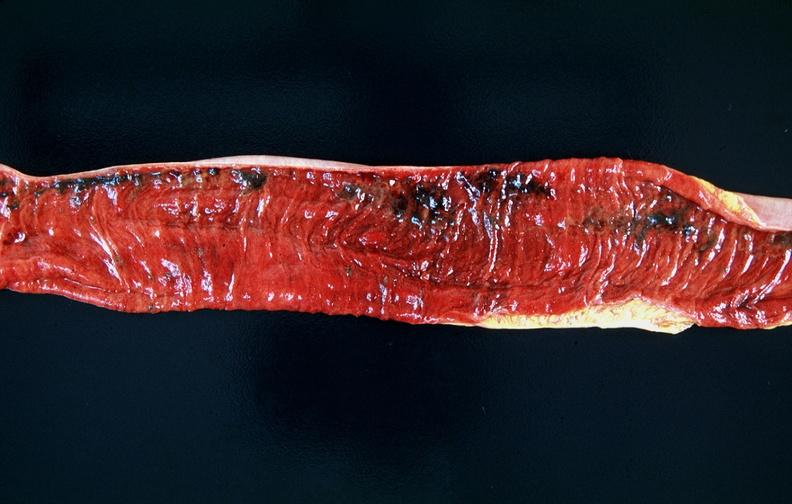does this image show small intestine, multifocal ulcers and hemorrhages, mucosal congestion?
Answer the question using a single word or phrase. Yes 